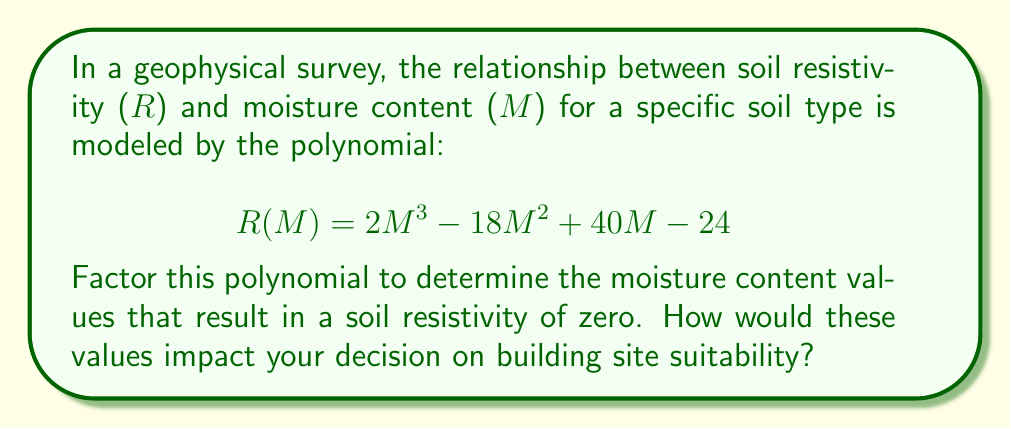Help me with this question. To factor this polynomial and find the moisture content values where soil resistivity is zero, we follow these steps:

1) First, we recognize that this is a cubic polynomial in the form:
   $$R(M) = 2M^3 - 18M^2 + 40M - 24$$

2) We need to find the roots of this polynomial, which are the values of M where R(M) = 0.

3) Let's try to factor out a common factor:
   $$2M^3 - 18M^2 + 40M - 24 = 2(M^3 - 9M^2 + 20M - 12)$$

4) Now, we can use the rational root theorem to find potential roots. The factors of the constant term (12) are: ±1, ±2, ±3, ±4, ±6, ±12.

5) Testing these values, we find that M = 2 is a root.

6) Dividing the polynomial by (M - 2), we get:
   $$2(M^3 - 9M^2 + 20M - 12) = 2(M - 2)(M^2 - 7M + 6)$$

7) The quadratic term $M^2 - 7M + 6$ can be factored as $(M - 1)(M - 6)$.

8) Therefore, the fully factored polynomial is:
   $$R(M) = 2(M - 2)(M - 1)(M - 6)$$

9) The roots of this polynomial are M = 2, M = 1, and M = 6.

These moisture content values (1%, 2%, and 6%) result in zero soil resistivity. For building site suitability:
- Very low moisture content (1-2%) might indicate overly dry soil, potentially leading to settling issues.
- Higher moisture content (6%) could suggest soil with good water retention, but possible risk of expansion or contraction.
- Values between these extremes might be ideal for construction, balancing stability and drainage.
Answer: $R(M) = 2(M - 2)(M - 1)(M - 6)$; roots: M = 1, 2, 6 